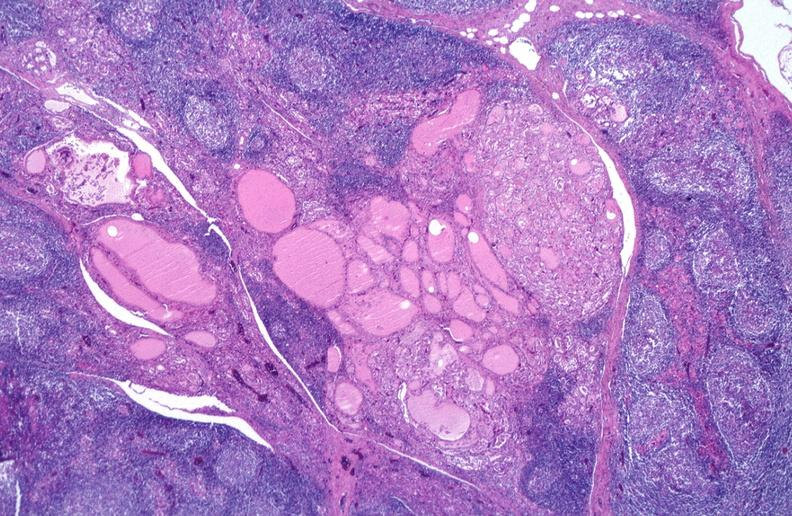what does this image show?
Answer the question using a single word or phrase. Hashimoto 's thyroiditis 